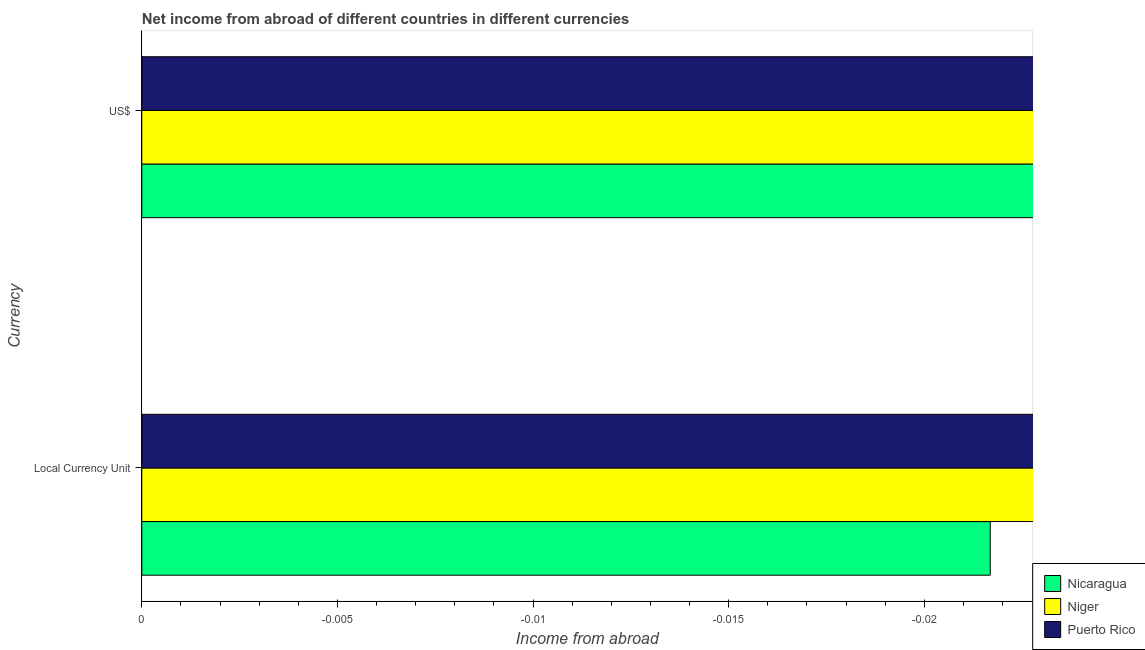How many different coloured bars are there?
Make the answer very short. 0. Are the number of bars on each tick of the Y-axis equal?
Provide a short and direct response. Yes. What is the label of the 2nd group of bars from the top?
Offer a very short reply. Local Currency Unit. What is the total income from abroad in constant 2005 us$ in the graph?
Provide a short and direct response. 0. What is the difference between the income from abroad in us$ in Niger and the income from abroad in constant 2005 us$ in Nicaragua?
Provide a short and direct response. 0. In how many countries, is the income from abroad in us$ greater than the average income from abroad in us$ taken over all countries?
Keep it short and to the point. 0. How many bars are there?
Your response must be concise. 0. What is the difference between two consecutive major ticks on the X-axis?
Provide a short and direct response. 0.01. Are the values on the major ticks of X-axis written in scientific E-notation?
Your response must be concise. No. Does the graph contain any zero values?
Offer a terse response. Yes. How are the legend labels stacked?
Provide a short and direct response. Vertical. What is the title of the graph?
Offer a very short reply. Net income from abroad of different countries in different currencies. What is the label or title of the X-axis?
Your answer should be compact. Income from abroad. What is the label or title of the Y-axis?
Keep it short and to the point. Currency. What is the Income from abroad in Nicaragua in Local Currency Unit?
Offer a terse response. 0. What is the Income from abroad of Puerto Rico in Local Currency Unit?
Give a very brief answer. 0. What is the Income from abroad of Nicaragua in US$?
Keep it short and to the point. 0. What is the Income from abroad of Niger in US$?
Provide a succinct answer. 0. What is the Income from abroad in Puerto Rico in US$?
Your answer should be very brief. 0. What is the total Income from abroad of Niger in the graph?
Your answer should be very brief. 0. What is the average Income from abroad in Puerto Rico per Currency?
Your answer should be very brief. 0. 